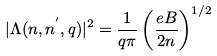Convert formula to latex. <formula><loc_0><loc_0><loc_500><loc_500>| \Lambda ( n , n ^ { ^ { \prime } } , q ) | ^ { 2 } = \frac { 1 } { q \pi } \left ( \frac { e B } { 2 n } \right ) ^ { 1 / 2 }</formula> 